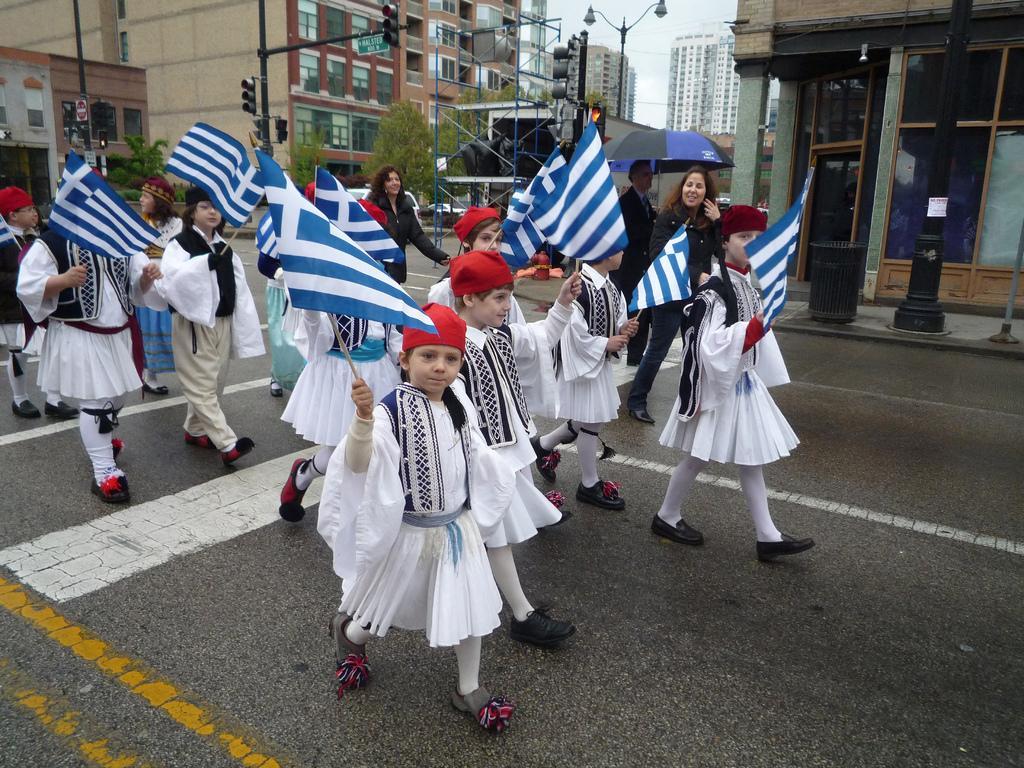Could you give a brief overview of what you see in this image? In this image we can see some persons walking on the road wearing similar dress holding some flags in their hands and at the background of the image there are some trees, traffic signals and buildings. 